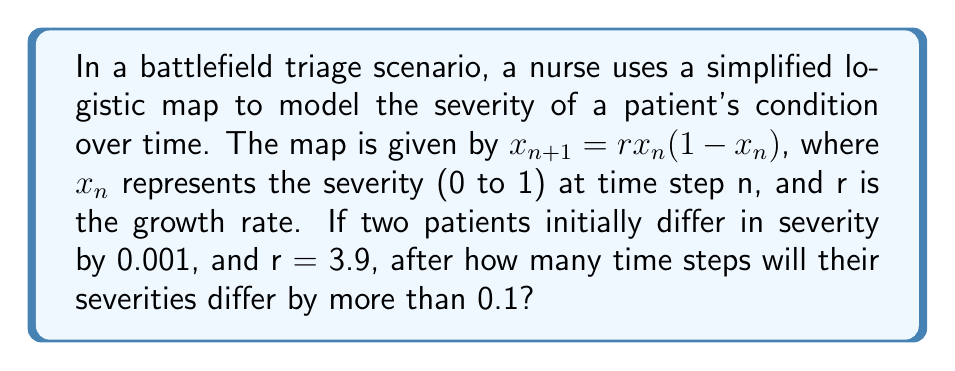Show me your answer to this math problem. To solve this problem, we need to iterate the logistic map for both patients and observe when their difference exceeds 0.1. Let's approach this step-by-step:

1) Let the initial conditions be $x_0 = 0.5$ for Patient A and $y_0 = 0.501$ for Patient B.

2) We'll use the logistic map equation: $x_{n+1} = rx_n(1-x_n)$ with $r = 3.9$

3) Let's iterate for both patients:

   For Patient A:
   $x_1 = 3.9 * 0.5 * (1-0.5) = 0.975$
   $x_2 = 3.9 * 0.975 * (1-0.975) = 0.0950625$
   $x_3 = 3.9 * 0.0950625 * (1-0.0950625) = 0.3352573$
   ...

   For Patient B:
   $y_1 = 3.9 * 0.501 * (1-0.501) = 0.974149$
   $y_2 = 3.9 * 0.974149 * (1-0.974149) = 0.0978503$
   $y_3 = 3.9 * 0.0978503 * (1-0.0978503) = 0.3441999$
   ...

4) We calculate the difference at each step:
   Step 1: $|0.975 - 0.974149| = 0.000851$
   Step 2: $|0.0950625 - 0.0978503| = 0.0027878$
   Step 3: $|0.3352573 - 0.3441999| = 0.0089426$
   Step 4: $|0.8681013 - 0.8776115| = 0.0095102$
   Step 5: $|0.4459161 - 0.4182433| = 0.0276728$
   Step 6: $|0.9634999 - 0.9482755| = 0.0152244$
   Step 7: $|0.1372065 - 0.1910736| = 0.0538671$
   Step 8: $|0.4614694 - 0.6013456| = 0.1398762$

5) We see that after 8 iterations, the difference exceeds 0.1.
Answer: 8 time steps 